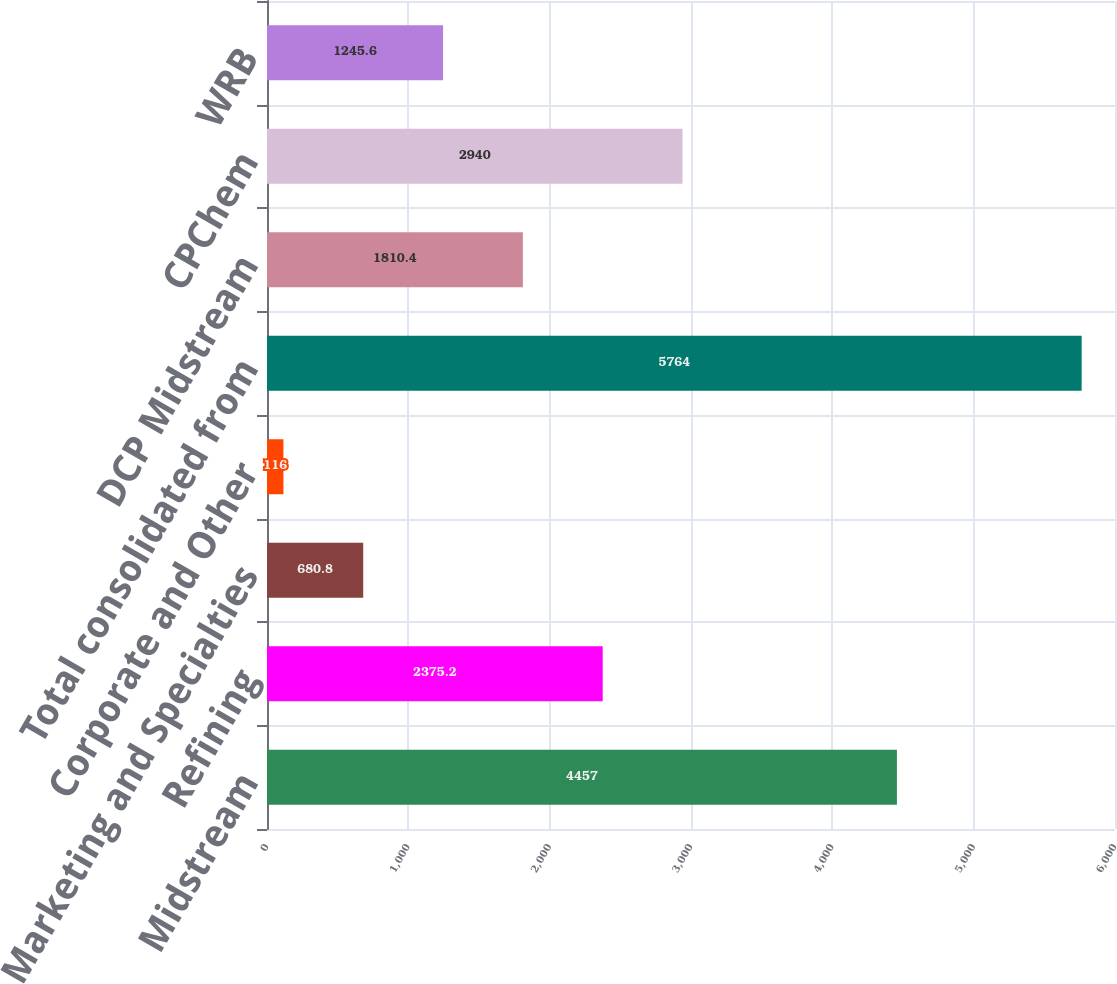Convert chart to OTSL. <chart><loc_0><loc_0><loc_500><loc_500><bar_chart><fcel>Midstream<fcel>Refining<fcel>Marketing and Specialties<fcel>Corporate and Other<fcel>Total consolidated from<fcel>DCP Midstream<fcel>CPChem<fcel>WRB<nl><fcel>4457<fcel>2375.2<fcel>680.8<fcel>116<fcel>5764<fcel>1810.4<fcel>2940<fcel>1245.6<nl></chart> 